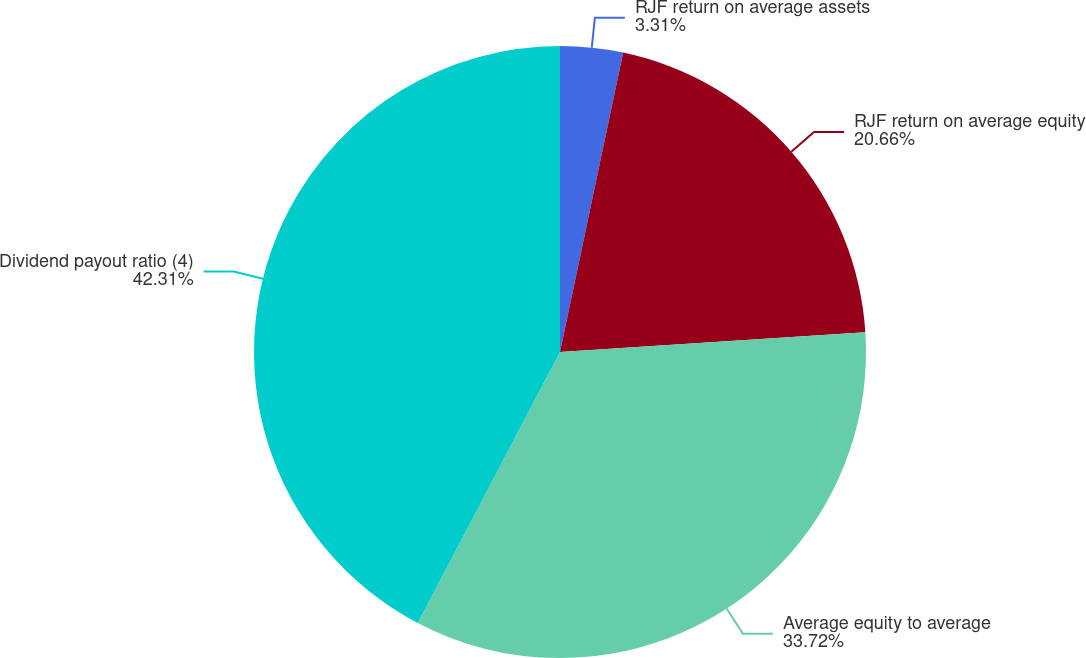<chart> <loc_0><loc_0><loc_500><loc_500><pie_chart><fcel>RJF return on average assets<fcel>RJF return on average equity<fcel>Average equity to average<fcel>Dividend payout ratio (4)<nl><fcel>3.31%<fcel>20.66%<fcel>33.72%<fcel>42.3%<nl></chart> 